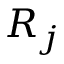<formula> <loc_0><loc_0><loc_500><loc_500>R _ { j }</formula> 